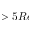<formula> <loc_0><loc_0><loc_500><loc_500>> 5 R e</formula> 